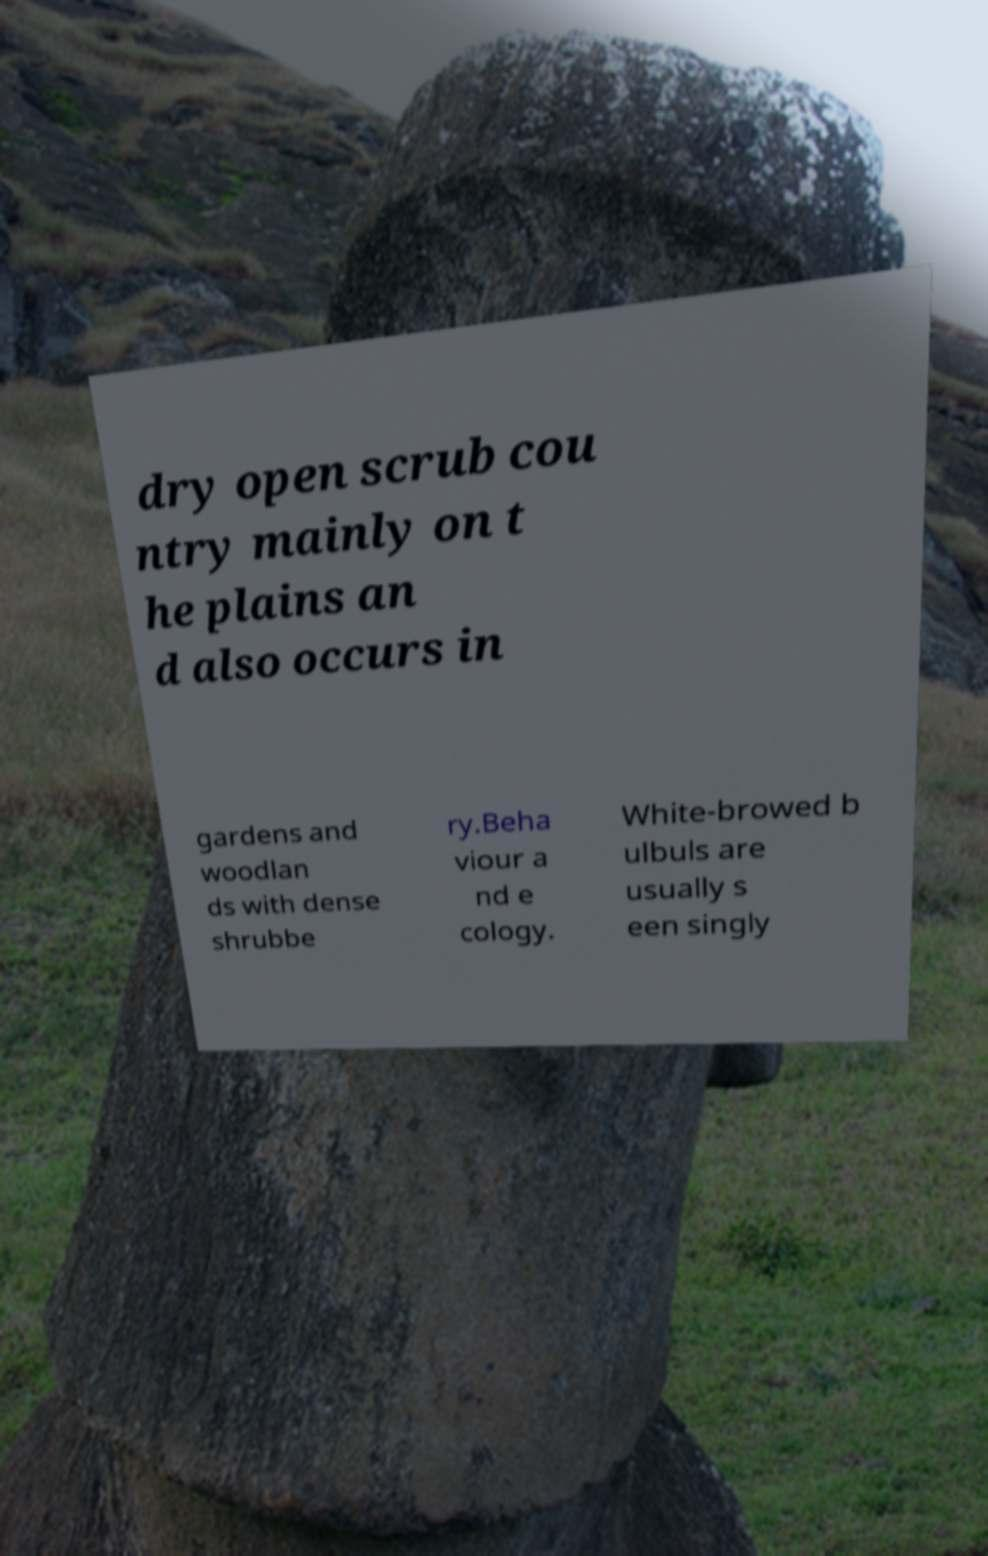Can you accurately transcribe the text from the provided image for me? dry open scrub cou ntry mainly on t he plains an d also occurs in gardens and woodlan ds with dense shrubbe ry.Beha viour a nd e cology. White-browed b ulbuls are usually s een singly 